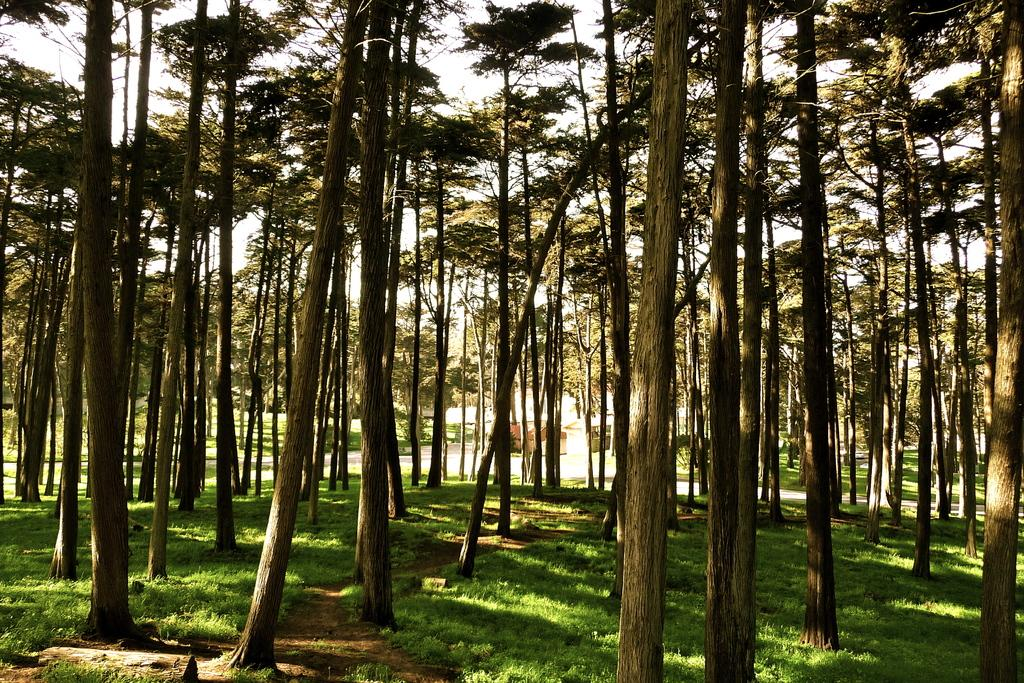Where was the image taken? The image was clicked outside. What type of vegetation is visible in the foreground of the image? There is green grass in the foreground of the image. What can be seen in the center of the image? There are trees in the center of the image. What is visible in the background of the image? The sky is visible in the background of the image. What else can be seen in the background of the image besides the sky? There are other objects in the background of the image. Is the person in the image feeling regret? There is no person visible in the image, so it is impossible to determine if they are feeling regret. 